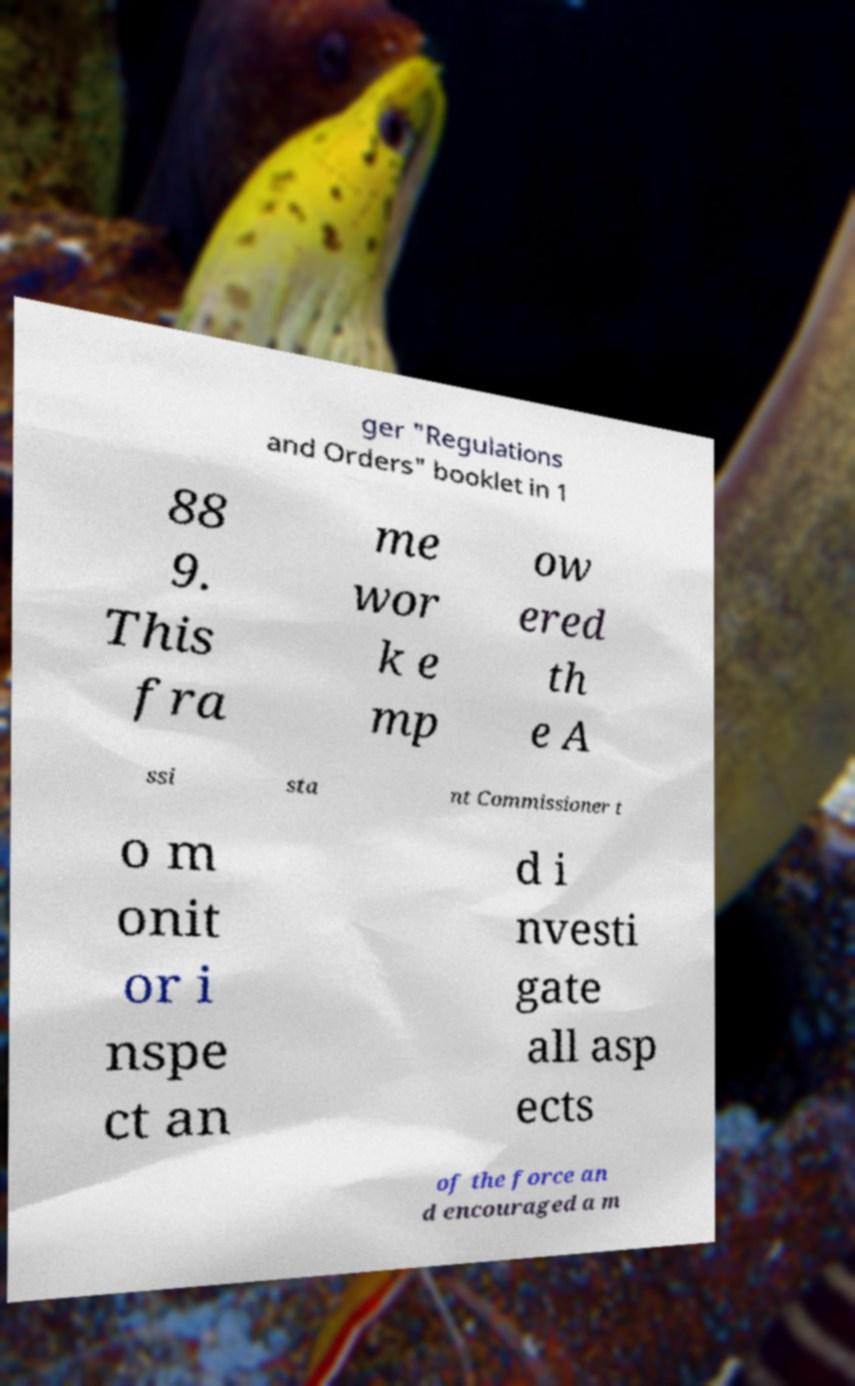Can you accurately transcribe the text from the provided image for me? ger "Regulations and Orders" booklet in 1 88 9. This fra me wor k e mp ow ered th e A ssi sta nt Commissioner t o m onit or i nspe ct an d i nvesti gate all asp ects of the force an d encouraged a m 